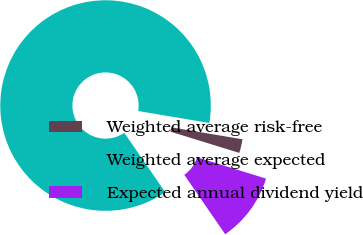Convert chart. <chart><loc_0><loc_0><loc_500><loc_500><pie_chart><fcel>Weighted average risk-free<fcel>Weighted average expected<fcel>Expected annual dividend yield<nl><fcel>2.12%<fcel>87.25%<fcel>10.63%<nl></chart> 